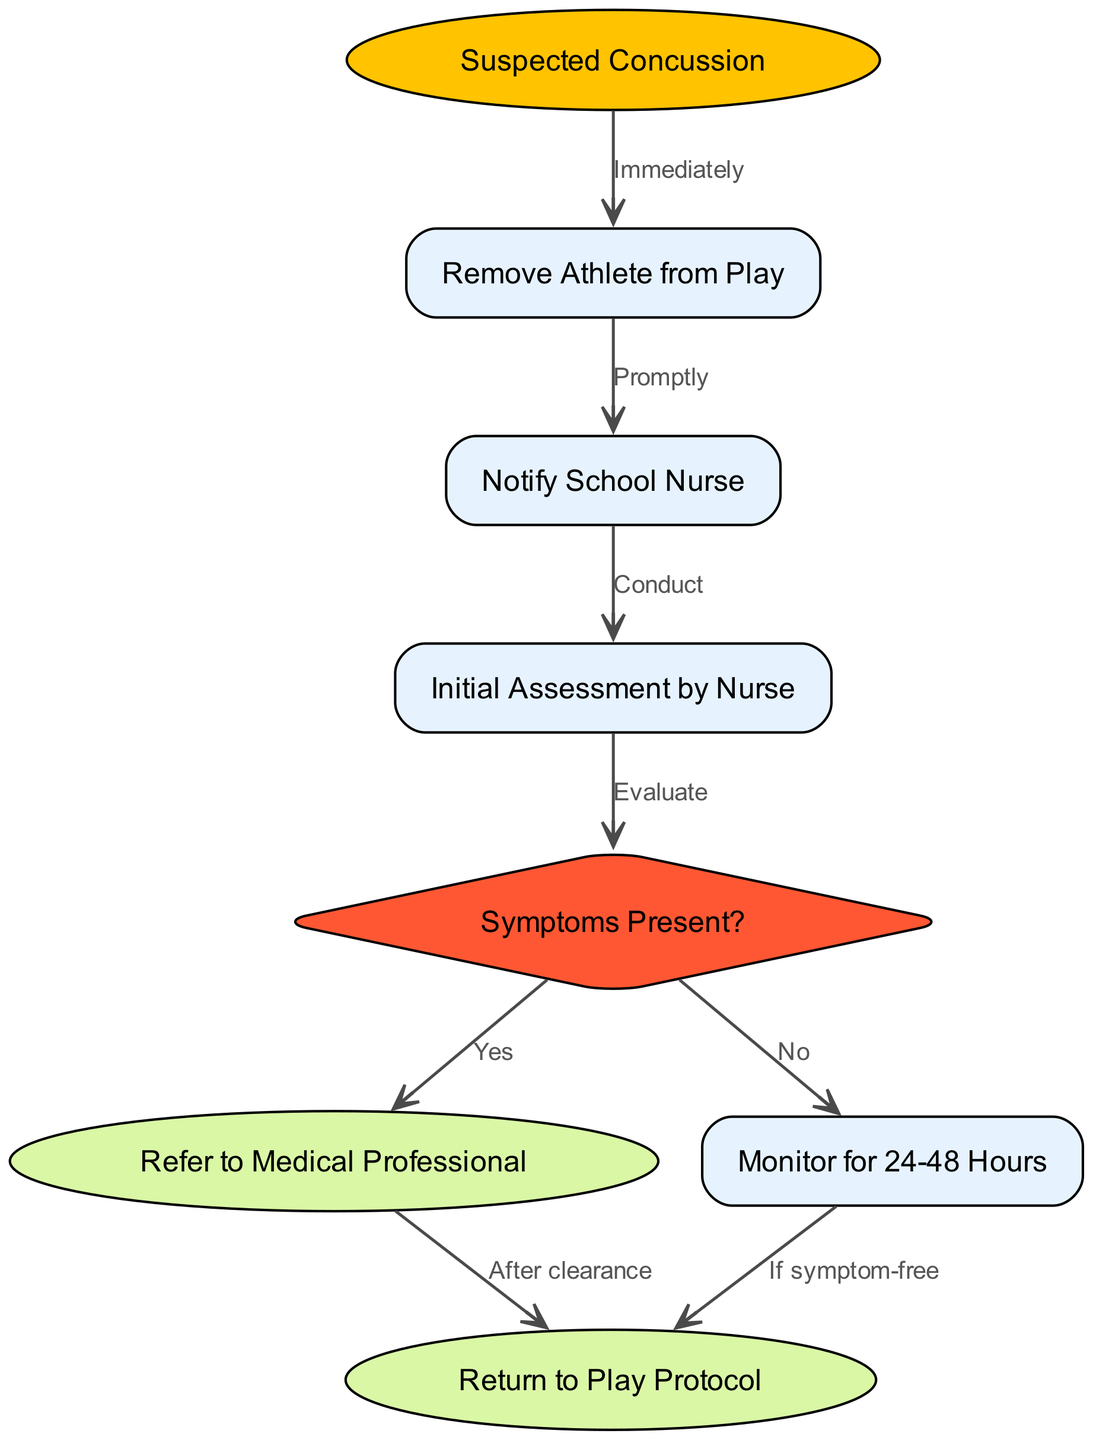What is the starting point of the flowchart? The starting point of the flowchart is labeled "Suspected Concussion," which indicates where the procedure begins.
Answer: Suspected Concussion How many nodes are in the diagram? The diagram contains a total of eight distinct nodes that represent different stages in the concussion assessment and management protocol.
Answer: 8 What action follows "Remove Athlete from Play"? The next action after "Remove Athlete from Play" is to "Notify School Nurse," which is the step that comes immediately after ensuring the player is out of action.
Answer: Notify School Nurse What decision needs to be made at "Initial Assessment by Nurse"? At the "Initial Assessment by Nurse," the decision to be made is whether "Symptoms Present?" which leads to the next steps based on the symptoms' presence.
Answer: Symptoms Present? If symptoms are present, what is the next step in the flowchart? If symptoms are present according to the decision node, the next step is to "Refer to Medical Professional", which indicates further medical evaluation is needed.
Answer: Refer to Medical Professional What should be done if there are no symptoms after monitoring? If the athlete is symptom-free after monitoring for 24-48 hours, the next step is to follow the "Return to Play Protocol," allowing the athlete to resume their activities safely.
Answer: Return to Play Protocol What is the purpose of the edge labeled "Evaluate"? The edge labeled "Evaluate" signifies the action taken during the "Initial Assessment by Nurse," where the nurse assesses the symptoms experienced by the athlete.
Answer: Evaluate How does the flowchart illustrate the relationship between "Notify School Nurse" and "Initial Assessment by Nurse"? The flowchart illustrates that the "Notify School Nurse" action directly leads to "Initial Assessment by Nurse," indicating that informing the nurse is a prerequisite to conducting the assessment.
Answer: Conduct 